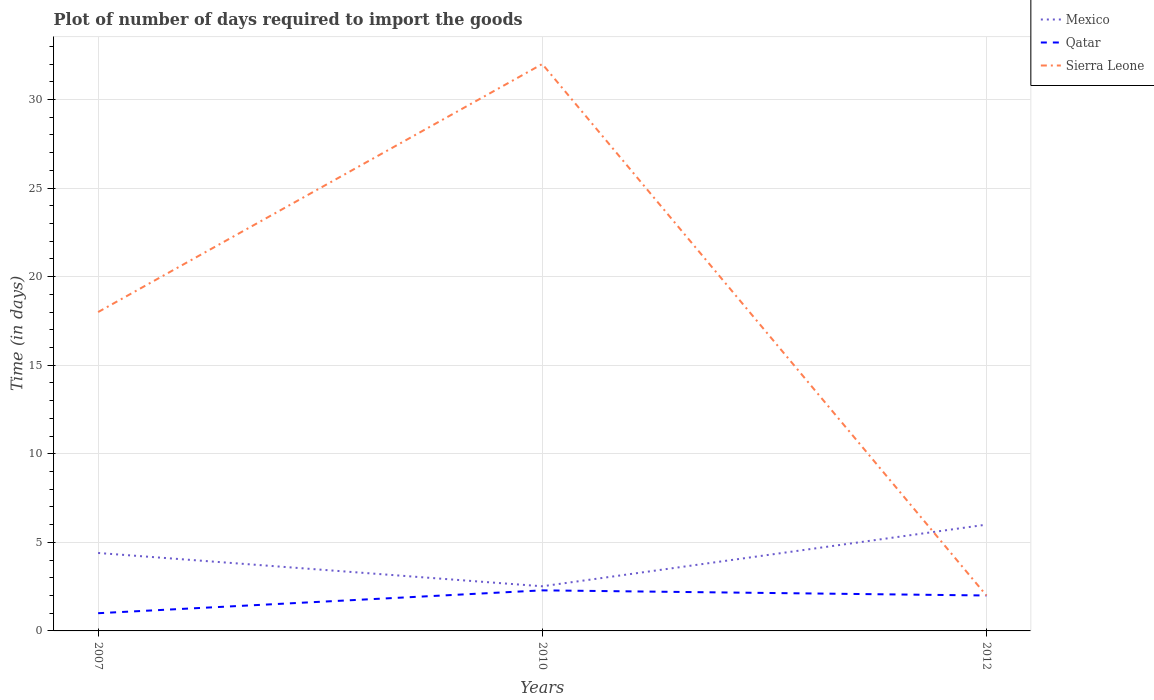How many different coloured lines are there?
Your response must be concise. 3. Is the number of lines equal to the number of legend labels?
Provide a short and direct response. Yes. Across all years, what is the maximum time required to import goods in Sierra Leone?
Ensure brevity in your answer.  2. What is the total time required to import goods in Qatar in the graph?
Make the answer very short. -1. What is the difference between the highest and the second highest time required to import goods in Mexico?
Give a very brief answer. 3.48. What is the difference between the highest and the lowest time required to import goods in Mexico?
Keep it short and to the point. 2. Is the time required to import goods in Sierra Leone strictly greater than the time required to import goods in Mexico over the years?
Ensure brevity in your answer.  No. Are the values on the major ticks of Y-axis written in scientific E-notation?
Offer a very short reply. No. How are the legend labels stacked?
Your answer should be very brief. Vertical. What is the title of the graph?
Your answer should be compact. Plot of number of days required to import the goods. Does "Tajikistan" appear as one of the legend labels in the graph?
Provide a succinct answer. No. What is the label or title of the Y-axis?
Offer a very short reply. Time (in days). What is the Time (in days) of Mexico in 2007?
Ensure brevity in your answer.  4.4. What is the Time (in days) in Sierra Leone in 2007?
Ensure brevity in your answer.  18. What is the Time (in days) of Mexico in 2010?
Give a very brief answer. 2.52. What is the Time (in days) of Qatar in 2010?
Provide a succinct answer. 2.29. What is the Time (in days) in Qatar in 2012?
Your response must be concise. 2. What is the Time (in days) of Sierra Leone in 2012?
Your answer should be very brief. 2. Across all years, what is the maximum Time (in days) of Mexico?
Your response must be concise. 6. Across all years, what is the maximum Time (in days) of Qatar?
Ensure brevity in your answer.  2.29. Across all years, what is the minimum Time (in days) in Mexico?
Make the answer very short. 2.52. Across all years, what is the minimum Time (in days) of Qatar?
Ensure brevity in your answer.  1. Across all years, what is the minimum Time (in days) of Sierra Leone?
Keep it short and to the point. 2. What is the total Time (in days) of Mexico in the graph?
Provide a short and direct response. 12.92. What is the total Time (in days) in Qatar in the graph?
Make the answer very short. 5.29. What is the total Time (in days) of Sierra Leone in the graph?
Make the answer very short. 52. What is the difference between the Time (in days) in Mexico in 2007 and that in 2010?
Provide a short and direct response. 1.88. What is the difference between the Time (in days) of Qatar in 2007 and that in 2010?
Your response must be concise. -1.29. What is the difference between the Time (in days) of Sierra Leone in 2007 and that in 2010?
Keep it short and to the point. -14. What is the difference between the Time (in days) of Mexico in 2007 and that in 2012?
Your answer should be compact. -1.6. What is the difference between the Time (in days) in Qatar in 2007 and that in 2012?
Your answer should be compact. -1. What is the difference between the Time (in days) of Sierra Leone in 2007 and that in 2012?
Give a very brief answer. 16. What is the difference between the Time (in days) of Mexico in 2010 and that in 2012?
Offer a terse response. -3.48. What is the difference between the Time (in days) in Qatar in 2010 and that in 2012?
Offer a very short reply. 0.29. What is the difference between the Time (in days) of Sierra Leone in 2010 and that in 2012?
Keep it short and to the point. 30. What is the difference between the Time (in days) in Mexico in 2007 and the Time (in days) in Qatar in 2010?
Keep it short and to the point. 2.11. What is the difference between the Time (in days) of Mexico in 2007 and the Time (in days) of Sierra Leone in 2010?
Ensure brevity in your answer.  -27.6. What is the difference between the Time (in days) in Qatar in 2007 and the Time (in days) in Sierra Leone in 2010?
Offer a terse response. -31. What is the difference between the Time (in days) of Mexico in 2007 and the Time (in days) of Qatar in 2012?
Make the answer very short. 2.4. What is the difference between the Time (in days) of Mexico in 2007 and the Time (in days) of Sierra Leone in 2012?
Provide a short and direct response. 2.4. What is the difference between the Time (in days) in Qatar in 2007 and the Time (in days) in Sierra Leone in 2012?
Make the answer very short. -1. What is the difference between the Time (in days) of Mexico in 2010 and the Time (in days) of Qatar in 2012?
Make the answer very short. 0.52. What is the difference between the Time (in days) in Mexico in 2010 and the Time (in days) in Sierra Leone in 2012?
Offer a terse response. 0.52. What is the difference between the Time (in days) in Qatar in 2010 and the Time (in days) in Sierra Leone in 2012?
Provide a succinct answer. 0.29. What is the average Time (in days) in Mexico per year?
Ensure brevity in your answer.  4.31. What is the average Time (in days) in Qatar per year?
Keep it short and to the point. 1.76. What is the average Time (in days) in Sierra Leone per year?
Your answer should be very brief. 17.33. In the year 2010, what is the difference between the Time (in days) of Mexico and Time (in days) of Qatar?
Make the answer very short. 0.23. In the year 2010, what is the difference between the Time (in days) of Mexico and Time (in days) of Sierra Leone?
Offer a terse response. -29.48. In the year 2010, what is the difference between the Time (in days) of Qatar and Time (in days) of Sierra Leone?
Offer a terse response. -29.71. In the year 2012, what is the difference between the Time (in days) of Qatar and Time (in days) of Sierra Leone?
Provide a succinct answer. 0. What is the ratio of the Time (in days) of Mexico in 2007 to that in 2010?
Keep it short and to the point. 1.75. What is the ratio of the Time (in days) in Qatar in 2007 to that in 2010?
Your answer should be very brief. 0.44. What is the ratio of the Time (in days) in Sierra Leone in 2007 to that in 2010?
Provide a succinct answer. 0.56. What is the ratio of the Time (in days) of Mexico in 2007 to that in 2012?
Your answer should be compact. 0.73. What is the ratio of the Time (in days) in Sierra Leone in 2007 to that in 2012?
Make the answer very short. 9. What is the ratio of the Time (in days) in Mexico in 2010 to that in 2012?
Give a very brief answer. 0.42. What is the ratio of the Time (in days) of Qatar in 2010 to that in 2012?
Offer a terse response. 1.15. What is the ratio of the Time (in days) in Sierra Leone in 2010 to that in 2012?
Provide a short and direct response. 16. What is the difference between the highest and the second highest Time (in days) in Qatar?
Keep it short and to the point. 0.29. What is the difference between the highest and the second highest Time (in days) of Sierra Leone?
Your answer should be compact. 14. What is the difference between the highest and the lowest Time (in days) in Mexico?
Make the answer very short. 3.48. What is the difference between the highest and the lowest Time (in days) in Qatar?
Ensure brevity in your answer.  1.29. 